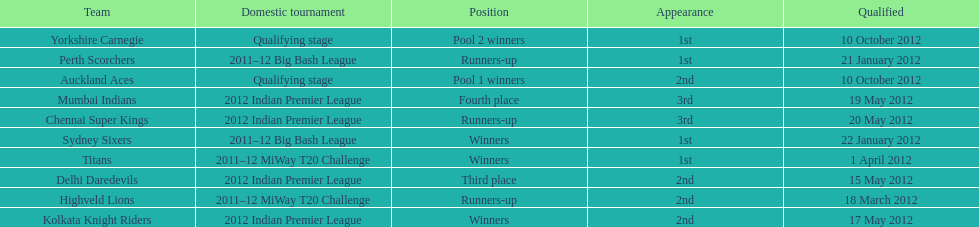The auckland aces and yorkshire carnegie qualified on what date? 10 October 2012. 